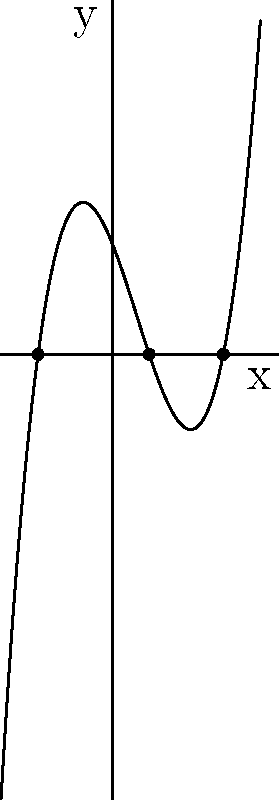Given the graph of a cubic polynomial $f(x)$, determine the sum of its roots. Assume the x-axis intersections are at whole number values. To find the sum of the roots of a cubic polynomial, we can follow these steps:

1. Identify the roots from the graph:
   The roots are the x-intercepts of the function, where $f(x) = 0$.
   From the graph, we can see that the roots are at $x = -2$, $x = 1$, and $x = 3$.

2. Recall the relationship between roots and coefficients:
   For a cubic polynomial $ax^3 + bx^2 + cx + d$, if $r_1$, $r_2$, and $r_3$ are the roots, then:
   $r_1 + r_2 + r_3 = -\frac{b}{a}$

3. Sum the roots:
   $(-2) + 1 + 3 = 2$

Therefore, the sum of the roots is 2.
Answer: 2 